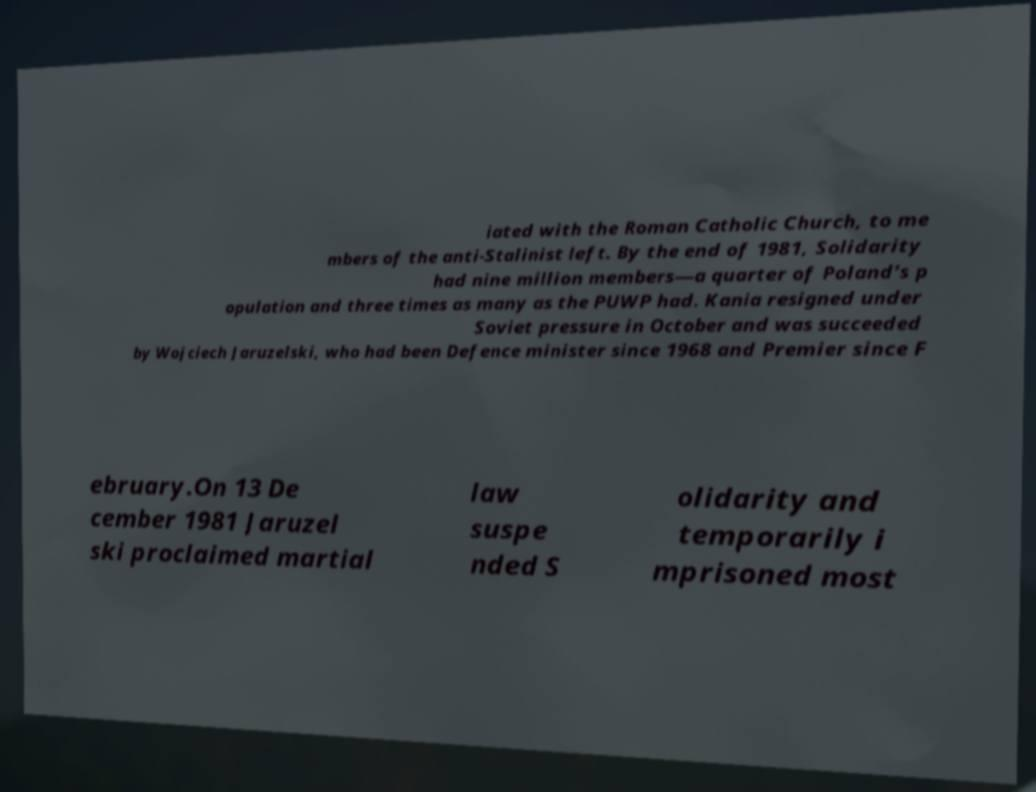Could you assist in decoding the text presented in this image and type it out clearly? iated with the Roman Catholic Church, to me mbers of the anti-Stalinist left. By the end of 1981, Solidarity had nine million members—a quarter of Poland's p opulation and three times as many as the PUWP had. Kania resigned under Soviet pressure in October and was succeeded by Wojciech Jaruzelski, who had been Defence minister since 1968 and Premier since F ebruary.On 13 De cember 1981 Jaruzel ski proclaimed martial law suspe nded S olidarity and temporarily i mprisoned most 